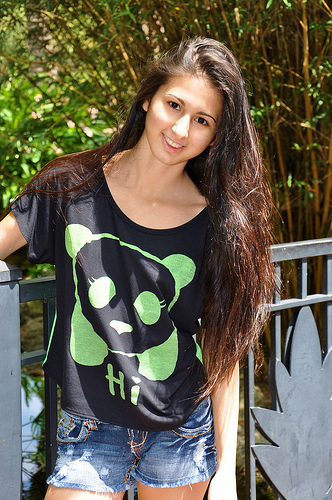<image>
Can you confirm if the girl is behind the gate? No. The girl is not behind the gate. From this viewpoint, the girl appears to be positioned elsewhere in the scene. 